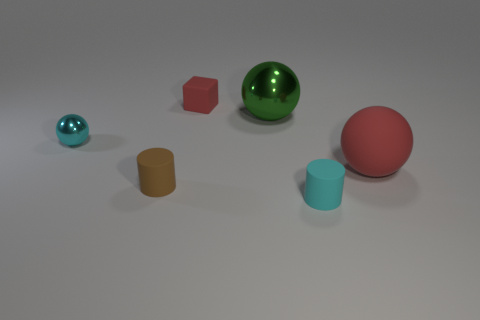If you had to guess, which two items might weigh the same? Without exact measurements, it's a bit speculative, but based on size and volume, one might guess that the red cube and the short blue cylinder could potentially weigh the same. Given that they share a visual simplicity and lack of detail that might imply a similar material density, their weights could be comparable. 